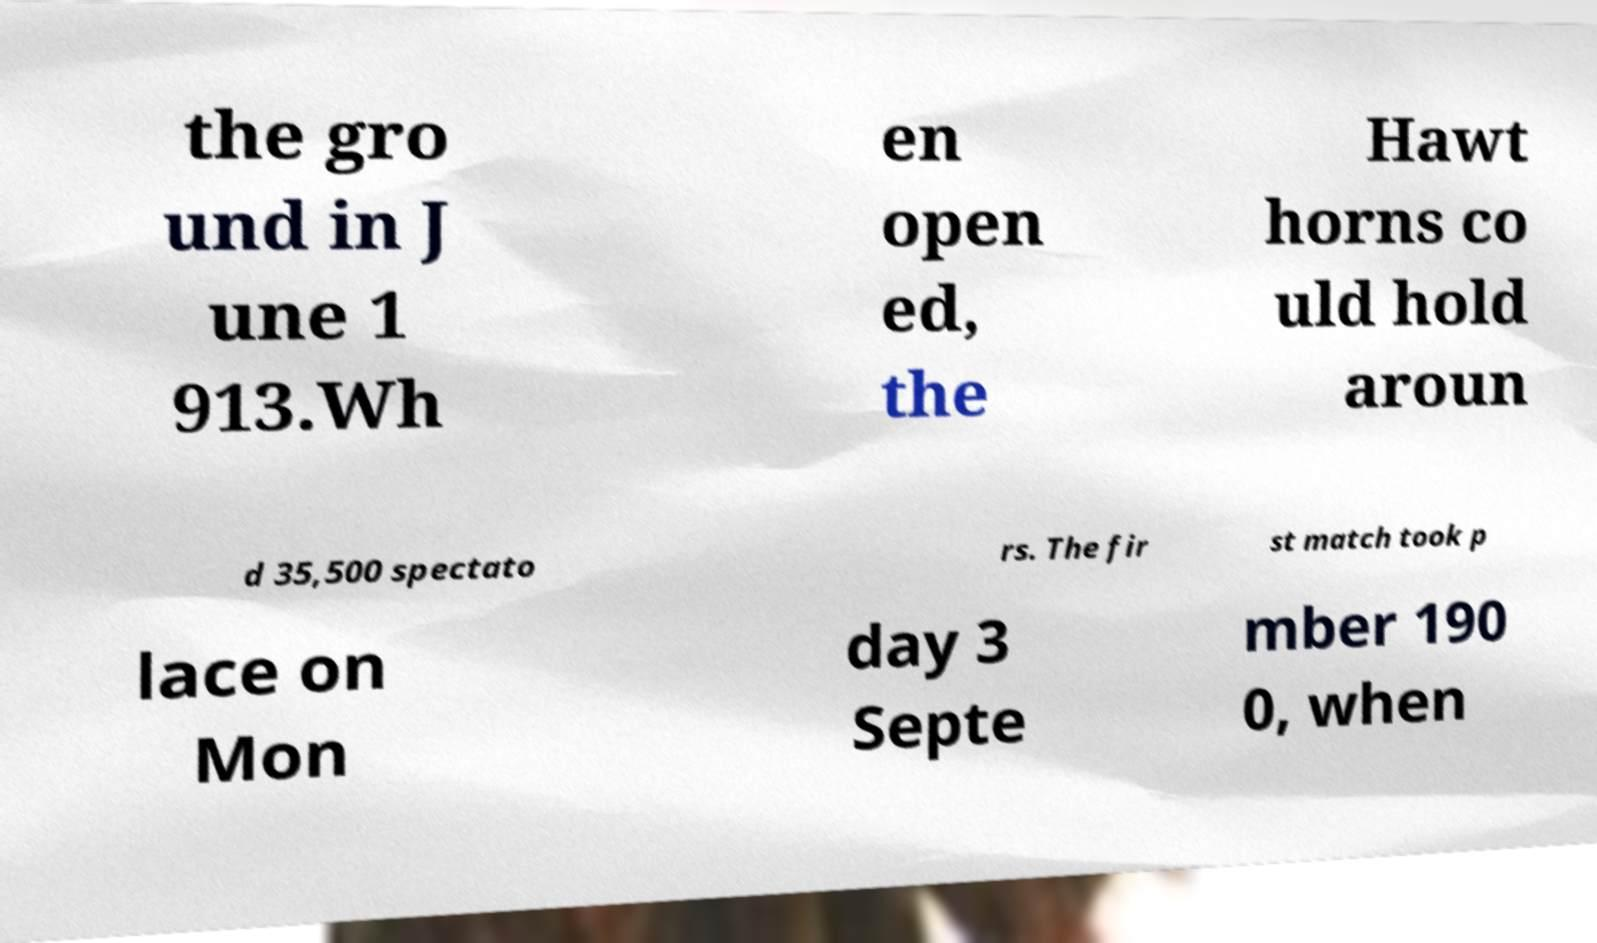Please identify and transcribe the text found in this image. the gro und in J une 1 913.Wh en open ed, the Hawt horns co uld hold aroun d 35,500 spectato rs. The fir st match took p lace on Mon day 3 Septe mber 190 0, when 